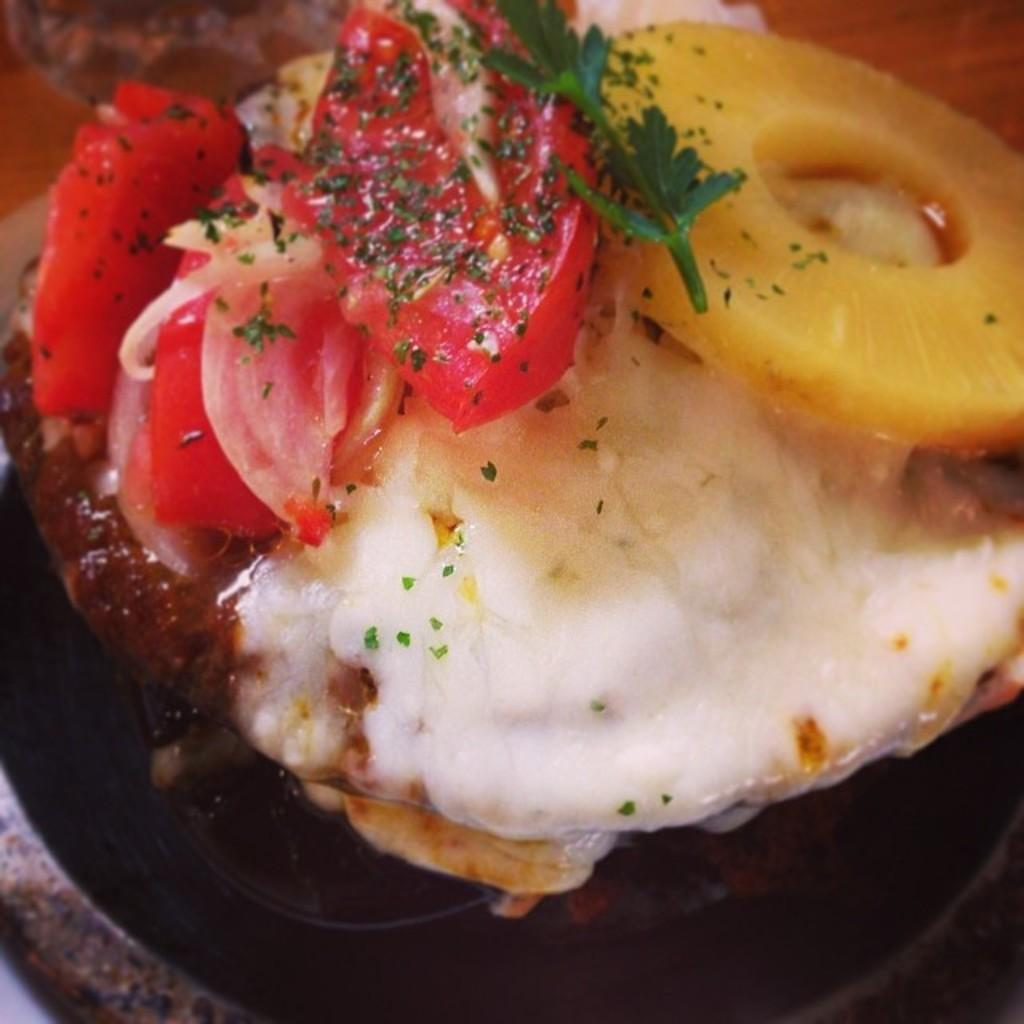What type of food can be seen in the image? There is food in the image, specifically tomato slices. Can you see any adjustments being made to the tomato slices in the image? There is no indication of any adjustments being made to the tomato slices in the image. Are there any visible toes in the image? There are no toes present in the image. 